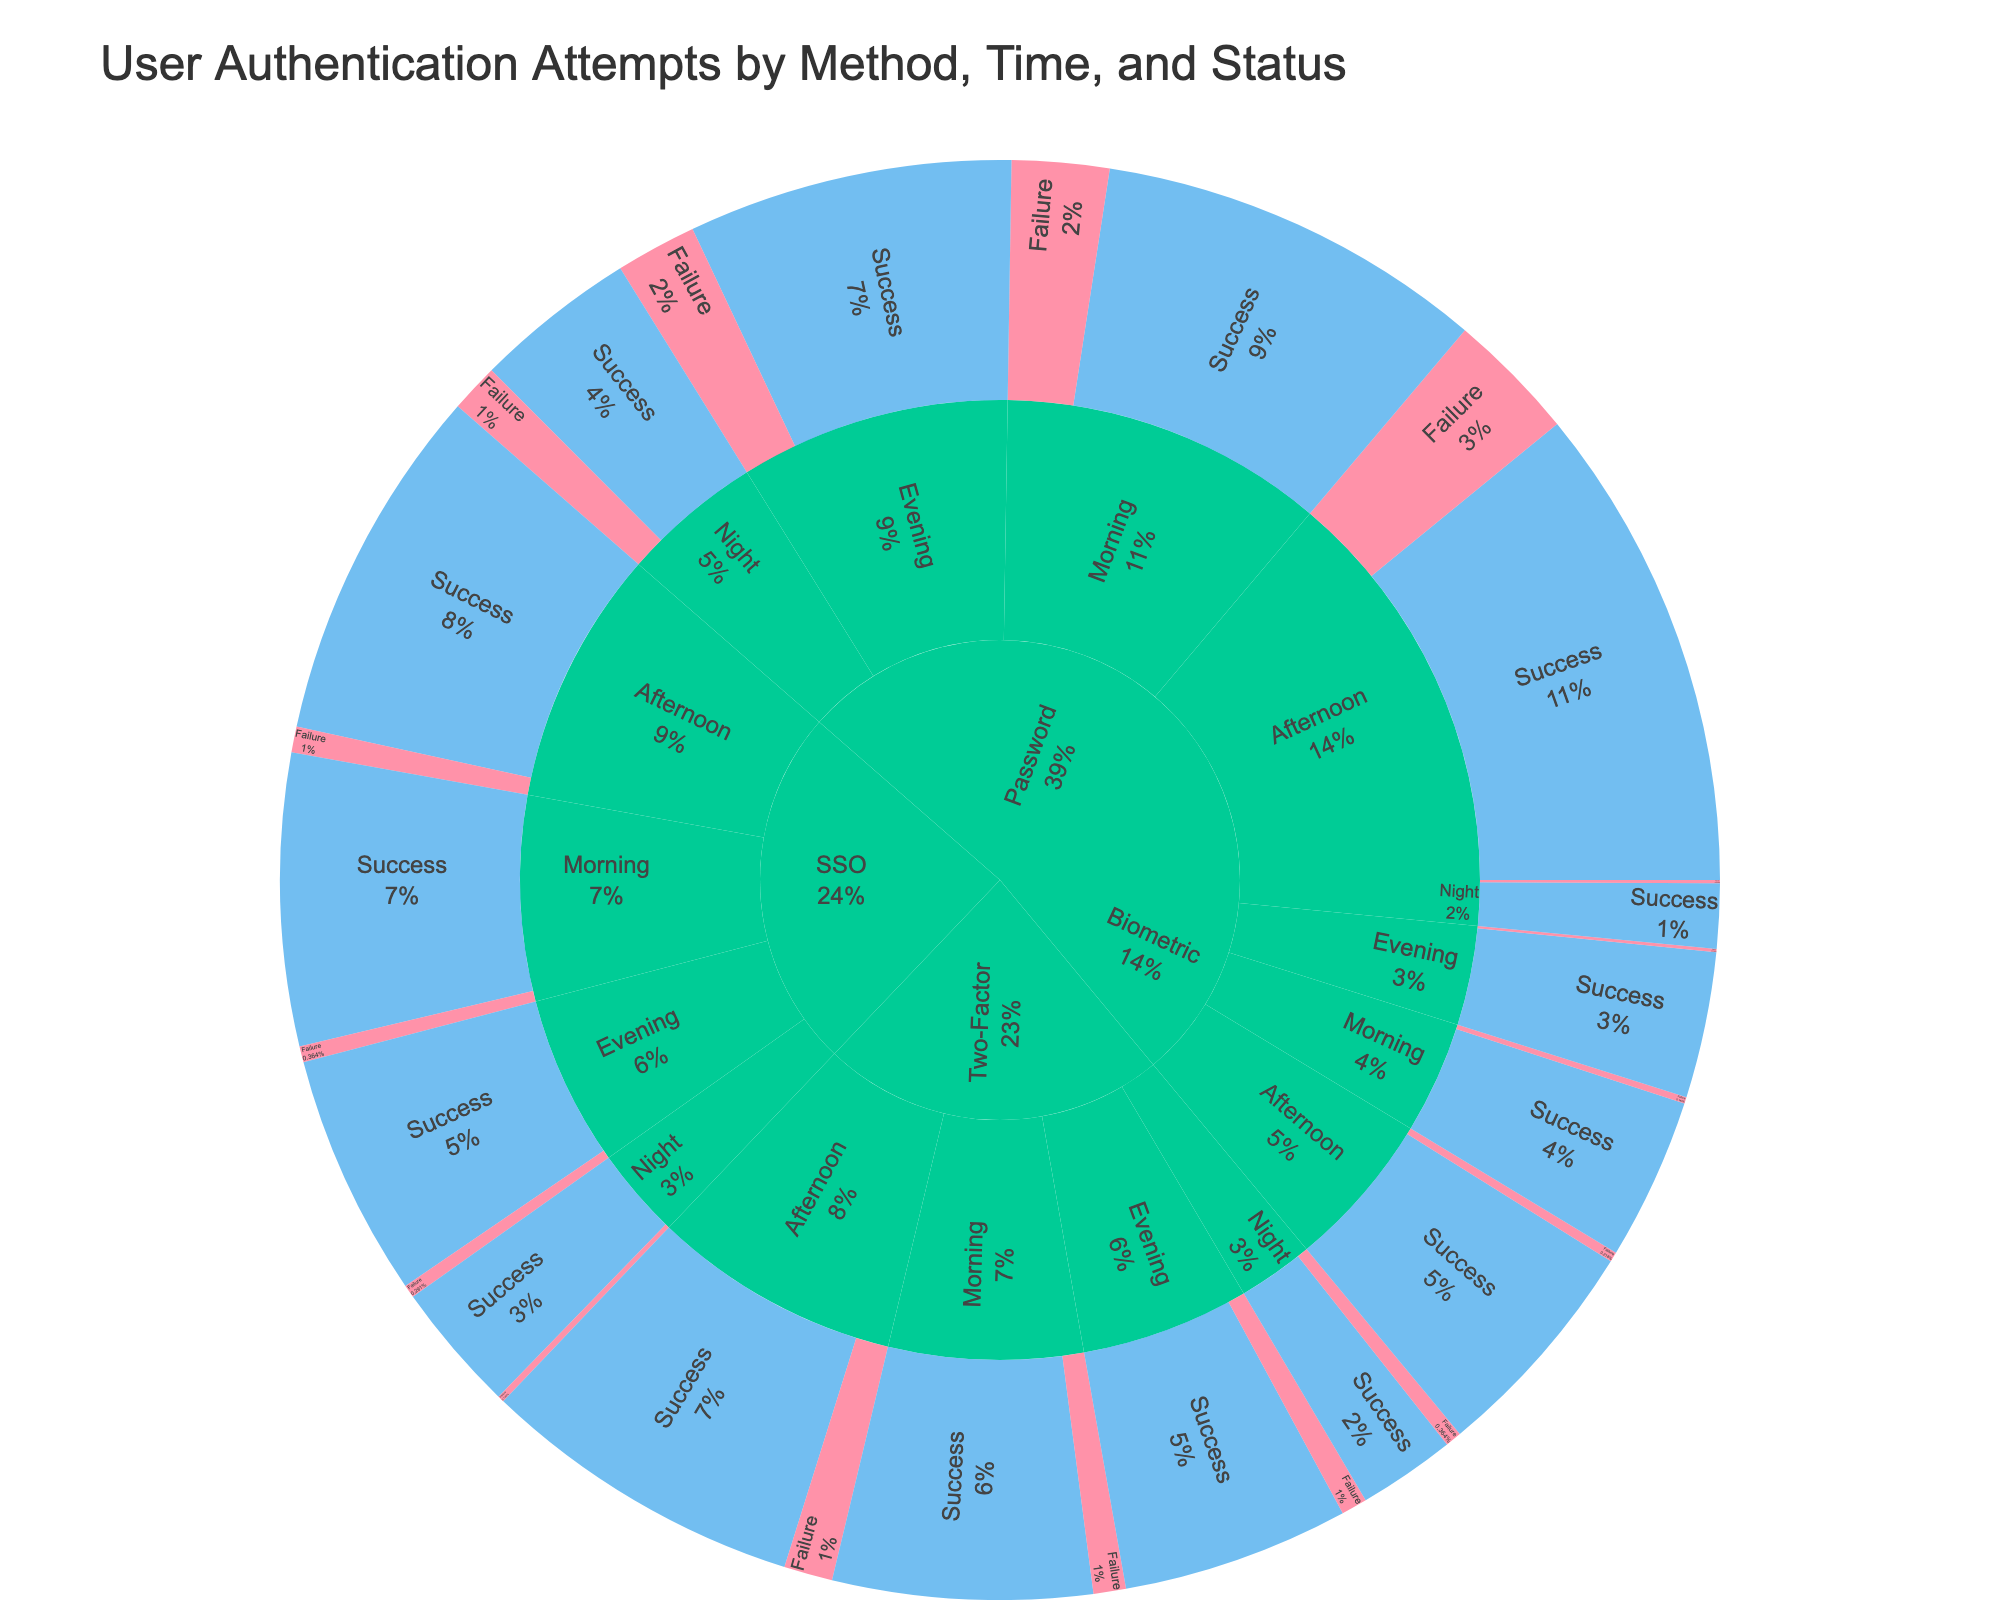What is the title of the figure? The title is typically located at the top of the figure. For this plot, the title reads 'User Authentication Attempts by Method, Time, and Status'.
Answer: User Authentication Attempts by Method, Time, and Status Which authentication method had the highest count of successful attempts during the afternoon? Look for the afternoon slice under each method and compare the "Success" values. Password had 150 successful attempts in the afternoon, beating others.
Answer: Password How many authentication attempts failed during the night for all methods combined? Sum the "Failure" counts for each method during the night. Password: 15, Two-Factor: 5, SSO: 2, Biometric: 1. Total = 15 + 5 + 2 + 1 = 23.
Answer: 23 During the morning, which method had a higher count of successful attempts: SSO or Two-Factor? Compare "Success" counts for SSO and Two-Factor during the morning. SSO had 90 successful attempts and Two-Factor had 80.
Answer: SSO What is the overall success rate for the Biometric method? Sum the total successful and failed attempts for Biometric, then calculate the success rate. Success: 50+70+45+20 = 185. Failure: 2+3+1+1 = 7. Total Attempts = 185 + 7 = 192. Success Rate = 185/192.
Answer: 96.4% Which time of day had the lowest number of successful Password attempts? Compare "Success" counts for Password across all times (Morning: 120, Afternoon: 150, Evening: 100, Night: 50). Night had the lowest successful attempts.
Answer: Night What is the ratio of failed to successful attempts for Two-Factor authentication in the evening? Look at the "Failure" and "Success" counts for Two-Factor in the evening. Failure: 8, Success: 70. Ratio = 8/70.
Answer: 0.11 How do the success rates of the different authentication methods compare during the night? Calculate success rates for each method during the night. Password: 50/65 = 76.9%, Two-Factor: 30/35 = 85.7%, SSO: 40/42 = 95.2%, Biometric: 20/21 = 95.2%.
Answer: Biometric/SSO > Two-Factor > Password Across all times, which method has the highest percentage of failed attempts? Calculate the failure percentage for each method. Password: 110/530, Two-Factor: 38/388, SSO: 19/438, Biometric: 7/192. Password has the highest percentage of failures.
Answer: Password 